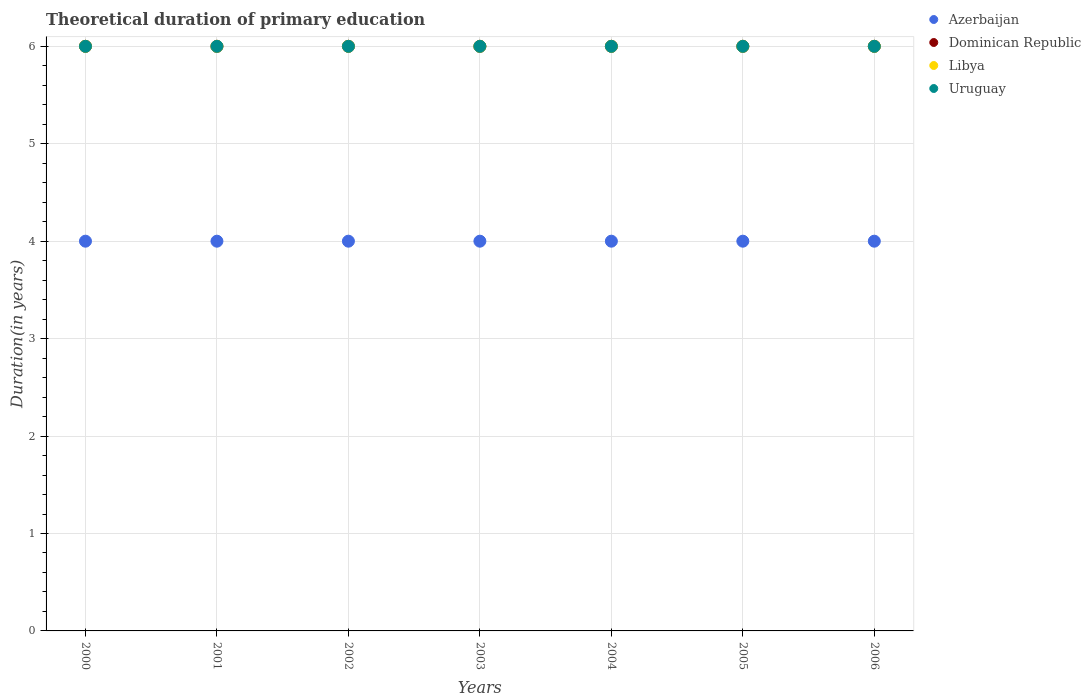Is the number of dotlines equal to the number of legend labels?
Offer a very short reply. Yes. What is the total theoretical duration of primary education in Azerbaijan in 2005?
Make the answer very short. 4. Across all years, what is the minimum total theoretical duration of primary education in Azerbaijan?
Your answer should be compact. 4. In which year was the total theoretical duration of primary education in Azerbaijan maximum?
Your answer should be compact. 2000. In which year was the total theoretical duration of primary education in Azerbaijan minimum?
Offer a very short reply. 2000. What is the total total theoretical duration of primary education in Uruguay in the graph?
Your answer should be compact. 42. What is the average total theoretical duration of primary education in Libya per year?
Make the answer very short. 6. In the year 2005, what is the difference between the total theoretical duration of primary education in Azerbaijan and total theoretical duration of primary education in Libya?
Offer a terse response. -2. In how many years, is the total theoretical duration of primary education in Dominican Republic greater than 2.2 years?
Keep it short and to the point. 7. What is the ratio of the total theoretical duration of primary education in Azerbaijan in 2002 to that in 2004?
Offer a very short reply. 1. Is the total theoretical duration of primary education in Dominican Republic in 2000 less than that in 2006?
Make the answer very short. No. Is the difference between the total theoretical duration of primary education in Azerbaijan in 2001 and 2003 greater than the difference between the total theoretical duration of primary education in Libya in 2001 and 2003?
Provide a succinct answer. No. What is the difference between the highest and the lowest total theoretical duration of primary education in Azerbaijan?
Offer a terse response. 0. Is the total theoretical duration of primary education in Dominican Republic strictly greater than the total theoretical duration of primary education in Uruguay over the years?
Your answer should be compact. No. Is the total theoretical duration of primary education in Azerbaijan strictly less than the total theoretical duration of primary education in Dominican Republic over the years?
Keep it short and to the point. Yes. How many years are there in the graph?
Your answer should be very brief. 7. Are the values on the major ticks of Y-axis written in scientific E-notation?
Keep it short and to the point. No. Does the graph contain grids?
Offer a terse response. Yes. Where does the legend appear in the graph?
Your answer should be compact. Top right. How are the legend labels stacked?
Give a very brief answer. Vertical. What is the title of the graph?
Make the answer very short. Theoretical duration of primary education. Does "United States" appear as one of the legend labels in the graph?
Ensure brevity in your answer.  No. What is the label or title of the Y-axis?
Make the answer very short. Duration(in years). What is the Duration(in years) in Dominican Republic in 2000?
Give a very brief answer. 6. What is the Duration(in years) of Uruguay in 2000?
Keep it short and to the point. 6. What is the Duration(in years) of Azerbaijan in 2001?
Provide a short and direct response. 4. What is the Duration(in years) in Dominican Republic in 2001?
Offer a terse response. 6. What is the Duration(in years) in Libya in 2001?
Your answer should be very brief. 6. What is the Duration(in years) in Uruguay in 2001?
Provide a short and direct response. 6. What is the Duration(in years) in Dominican Republic in 2002?
Make the answer very short. 6. What is the Duration(in years) in Uruguay in 2002?
Ensure brevity in your answer.  6. What is the Duration(in years) in Libya in 2003?
Offer a very short reply. 6. What is the Duration(in years) in Uruguay in 2003?
Your response must be concise. 6. What is the Duration(in years) in Dominican Republic in 2004?
Provide a short and direct response. 6. What is the Duration(in years) in Libya in 2005?
Provide a succinct answer. 6. What is the Duration(in years) in Uruguay in 2005?
Keep it short and to the point. 6. What is the Duration(in years) of Azerbaijan in 2006?
Give a very brief answer. 4. What is the Duration(in years) in Libya in 2006?
Keep it short and to the point. 6. What is the Duration(in years) in Uruguay in 2006?
Offer a terse response. 6. Across all years, what is the maximum Duration(in years) of Azerbaijan?
Offer a terse response. 4. Across all years, what is the maximum Duration(in years) in Libya?
Your answer should be compact. 6. Across all years, what is the maximum Duration(in years) in Uruguay?
Give a very brief answer. 6. Across all years, what is the minimum Duration(in years) in Azerbaijan?
Ensure brevity in your answer.  4. Across all years, what is the minimum Duration(in years) in Libya?
Give a very brief answer. 6. What is the total Duration(in years) of Azerbaijan in the graph?
Your response must be concise. 28. What is the total Duration(in years) of Dominican Republic in the graph?
Ensure brevity in your answer.  42. What is the total Duration(in years) in Libya in the graph?
Provide a succinct answer. 42. What is the difference between the Duration(in years) in Dominican Republic in 2000 and that in 2001?
Keep it short and to the point. 0. What is the difference between the Duration(in years) in Libya in 2000 and that in 2001?
Provide a succinct answer. 0. What is the difference between the Duration(in years) in Azerbaijan in 2000 and that in 2002?
Provide a succinct answer. 0. What is the difference between the Duration(in years) of Uruguay in 2000 and that in 2002?
Your answer should be compact. 0. What is the difference between the Duration(in years) in Uruguay in 2000 and that in 2003?
Make the answer very short. 0. What is the difference between the Duration(in years) in Azerbaijan in 2000 and that in 2004?
Ensure brevity in your answer.  0. What is the difference between the Duration(in years) in Dominican Republic in 2000 and that in 2004?
Provide a succinct answer. 0. What is the difference between the Duration(in years) in Libya in 2000 and that in 2005?
Your answer should be compact. 0. What is the difference between the Duration(in years) in Dominican Republic in 2000 and that in 2006?
Your answer should be compact. 0. What is the difference between the Duration(in years) of Libya in 2000 and that in 2006?
Keep it short and to the point. 0. What is the difference between the Duration(in years) in Uruguay in 2000 and that in 2006?
Your answer should be very brief. 0. What is the difference between the Duration(in years) in Dominican Republic in 2001 and that in 2003?
Give a very brief answer. 0. What is the difference between the Duration(in years) of Libya in 2001 and that in 2003?
Give a very brief answer. 0. What is the difference between the Duration(in years) in Uruguay in 2001 and that in 2004?
Offer a very short reply. 0. What is the difference between the Duration(in years) of Azerbaijan in 2001 and that in 2005?
Offer a terse response. 0. What is the difference between the Duration(in years) in Libya in 2001 and that in 2005?
Provide a short and direct response. 0. What is the difference between the Duration(in years) in Azerbaijan in 2001 and that in 2006?
Provide a succinct answer. 0. What is the difference between the Duration(in years) in Libya in 2001 and that in 2006?
Give a very brief answer. 0. What is the difference between the Duration(in years) in Uruguay in 2001 and that in 2006?
Your answer should be compact. 0. What is the difference between the Duration(in years) of Azerbaijan in 2002 and that in 2003?
Make the answer very short. 0. What is the difference between the Duration(in years) in Libya in 2002 and that in 2003?
Your response must be concise. 0. What is the difference between the Duration(in years) of Azerbaijan in 2002 and that in 2004?
Provide a short and direct response. 0. What is the difference between the Duration(in years) in Dominican Republic in 2002 and that in 2004?
Give a very brief answer. 0. What is the difference between the Duration(in years) in Azerbaijan in 2002 and that in 2005?
Your response must be concise. 0. What is the difference between the Duration(in years) of Dominican Republic in 2002 and that in 2005?
Your answer should be very brief. 0. What is the difference between the Duration(in years) of Azerbaijan in 2002 and that in 2006?
Ensure brevity in your answer.  0. What is the difference between the Duration(in years) in Dominican Republic in 2002 and that in 2006?
Offer a very short reply. 0. What is the difference between the Duration(in years) of Azerbaijan in 2003 and that in 2004?
Offer a very short reply. 0. What is the difference between the Duration(in years) of Dominican Republic in 2003 and that in 2004?
Make the answer very short. 0. What is the difference between the Duration(in years) of Uruguay in 2003 and that in 2004?
Provide a succinct answer. 0. What is the difference between the Duration(in years) in Dominican Republic in 2003 and that in 2005?
Provide a succinct answer. 0. What is the difference between the Duration(in years) of Uruguay in 2003 and that in 2005?
Your response must be concise. 0. What is the difference between the Duration(in years) of Azerbaijan in 2003 and that in 2006?
Offer a terse response. 0. What is the difference between the Duration(in years) of Uruguay in 2003 and that in 2006?
Your answer should be very brief. 0. What is the difference between the Duration(in years) in Azerbaijan in 2004 and that in 2005?
Provide a succinct answer. 0. What is the difference between the Duration(in years) in Dominican Republic in 2004 and that in 2005?
Give a very brief answer. 0. What is the difference between the Duration(in years) of Libya in 2004 and that in 2005?
Provide a short and direct response. 0. What is the difference between the Duration(in years) in Uruguay in 2004 and that in 2005?
Ensure brevity in your answer.  0. What is the difference between the Duration(in years) of Azerbaijan in 2004 and that in 2006?
Your answer should be very brief. 0. What is the difference between the Duration(in years) of Dominican Republic in 2004 and that in 2006?
Your answer should be compact. 0. What is the difference between the Duration(in years) in Azerbaijan in 2000 and the Duration(in years) in Libya in 2001?
Provide a short and direct response. -2. What is the difference between the Duration(in years) of Dominican Republic in 2000 and the Duration(in years) of Libya in 2001?
Make the answer very short. 0. What is the difference between the Duration(in years) in Libya in 2000 and the Duration(in years) in Uruguay in 2001?
Offer a very short reply. 0. What is the difference between the Duration(in years) in Azerbaijan in 2000 and the Duration(in years) in Uruguay in 2002?
Offer a very short reply. -2. What is the difference between the Duration(in years) of Dominican Republic in 2000 and the Duration(in years) of Libya in 2002?
Make the answer very short. 0. What is the difference between the Duration(in years) of Libya in 2000 and the Duration(in years) of Uruguay in 2002?
Your answer should be compact. 0. What is the difference between the Duration(in years) in Azerbaijan in 2000 and the Duration(in years) in Dominican Republic in 2003?
Give a very brief answer. -2. What is the difference between the Duration(in years) in Dominican Republic in 2000 and the Duration(in years) in Uruguay in 2003?
Offer a very short reply. 0. What is the difference between the Duration(in years) in Azerbaijan in 2000 and the Duration(in years) in Libya in 2004?
Ensure brevity in your answer.  -2. What is the difference between the Duration(in years) of Dominican Republic in 2000 and the Duration(in years) of Libya in 2004?
Ensure brevity in your answer.  0. What is the difference between the Duration(in years) of Libya in 2000 and the Duration(in years) of Uruguay in 2004?
Offer a very short reply. 0. What is the difference between the Duration(in years) of Azerbaijan in 2000 and the Duration(in years) of Dominican Republic in 2005?
Keep it short and to the point. -2. What is the difference between the Duration(in years) in Dominican Republic in 2000 and the Duration(in years) in Libya in 2005?
Ensure brevity in your answer.  0. What is the difference between the Duration(in years) in Dominican Republic in 2000 and the Duration(in years) in Uruguay in 2005?
Offer a terse response. 0. What is the difference between the Duration(in years) in Libya in 2000 and the Duration(in years) in Uruguay in 2005?
Keep it short and to the point. 0. What is the difference between the Duration(in years) of Dominican Republic in 2000 and the Duration(in years) of Uruguay in 2006?
Your answer should be compact. 0. What is the difference between the Duration(in years) in Libya in 2000 and the Duration(in years) in Uruguay in 2006?
Your answer should be very brief. 0. What is the difference between the Duration(in years) of Dominican Republic in 2001 and the Duration(in years) of Libya in 2002?
Offer a terse response. 0. What is the difference between the Duration(in years) of Dominican Republic in 2001 and the Duration(in years) of Uruguay in 2002?
Your response must be concise. 0. What is the difference between the Duration(in years) in Libya in 2001 and the Duration(in years) in Uruguay in 2002?
Provide a short and direct response. 0. What is the difference between the Duration(in years) in Azerbaijan in 2001 and the Duration(in years) in Dominican Republic in 2003?
Offer a very short reply. -2. What is the difference between the Duration(in years) in Azerbaijan in 2001 and the Duration(in years) in Uruguay in 2003?
Ensure brevity in your answer.  -2. What is the difference between the Duration(in years) in Dominican Republic in 2001 and the Duration(in years) in Uruguay in 2003?
Your answer should be very brief. 0. What is the difference between the Duration(in years) of Azerbaijan in 2001 and the Duration(in years) of Dominican Republic in 2004?
Offer a very short reply. -2. What is the difference between the Duration(in years) in Azerbaijan in 2001 and the Duration(in years) in Libya in 2005?
Ensure brevity in your answer.  -2. What is the difference between the Duration(in years) in Dominican Republic in 2001 and the Duration(in years) in Libya in 2005?
Give a very brief answer. 0. What is the difference between the Duration(in years) in Dominican Republic in 2001 and the Duration(in years) in Uruguay in 2005?
Your answer should be compact. 0. What is the difference between the Duration(in years) of Dominican Republic in 2001 and the Duration(in years) of Uruguay in 2006?
Ensure brevity in your answer.  0. What is the difference between the Duration(in years) in Azerbaijan in 2002 and the Duration(in years) in Libya in 2003?
Ensure brevity in your answer.  -2. What is the difference between the Duration(in years) in Azerbaijan in 2002 and the Duration(in years) in Uruguay in 2003?
Provide a short and direct response. -2. What is the difference between the Duration(in years) in Dominican Republic in 2002 and the Duration(in years) in Libya in 2003?
Your answer should be very brief. 0. What is the difference between the Duration(in years) of Dominican Republic in 2002 and the Duration(in years) of Uruguay in 2003?
Your answer should be very brief. 0. What is the difference between the Duration(in years) of Azerbaijan in 2002 and the Duration(in years) of Uruguay in 2004?
Provide a short and direct response. -2. What is the difference between the Duration(in years) of Dominican Republic in 2002 and the Duration(in years) of Libya in 2004?
Your answer should be compact. 0. What is the difference between the Duration(in years) of Azerbaijan in 2002 and the Duration(in years) of Uruguay in 2005?
Keep it short and to the point. -2. What is the difference between the Duration(in years) of Dominican Republic in 2002 and the Duration(in years) of Libya in 2005?
Keep it short and to the point. 0. What is the difference between the Duration(in years) in Dominican Republic in 2002 and the Duration(in years) in Uruguay in 2005?
Make the answer very short. 0. What is the difference between the Duration(in years) in Libya in 2002 and the Duration(in years) in Uruguay in 2005?
Give a very brief answer. 0. What is the difference between the Duration(in years) in Dominican Republic in 2002 and the Duration(in years) in Uruguay in 2006?
Your response must be concise. 0. What is the difference between the Duration(in years) in Libya in 2002 and the Duration(in years) in Uruguay in 2006?
Your response must be concise. 0. What is the difference between the Duration(in years) of Azerbaijan in 2003 and the Duration(in years) of Libya in 2004?
Offer a terse response. -2. What is the difference between the Duration(in years) in Azerbaijan in 2003 and the Duration(in years) in Uruguay in 2004?
Keep it short and to the point. -2. What is the difference between the Duration(in years) in Dominican Republic in 2003 and the Duration(in years) in Libya in 2004?
Ensure brevity in your answer.  0. What is the difference between the Duration(in years) in Dominican Republic in 2003 and the Duration(in years) in Uruguay in 2004?
Provide a succinct answer. 0. What is the difference between the Duration(in years) of Libya in 2003 and the Duration(in years) of Uruguay in 2004?
Make the answer very short. 0. What is the difference between the Duration(in years) of Azerbaijan in 2003 and the Duration(in years) of Dominican Republic in 2005?
Your answer should be compact. -2. What is the difference between the Duration(in years) of Azerbaijan in 2003 and the Duration(in years) of Libya in 2005?
Ensure brevity in your answer.  -2. What is the difference between the Duration(in years) of Azerbaijan in 2003 and the Duration(in years) of Uruguay in 2005?
Ensure brevity in your answer.  -2. What is the difference between the Duration(in years) of Dominican Republic in 2003 and the Duration(in years) of Libya in 2005?
Offer a terse response. 0. What is the difference between the Duration(in years) in Azerbaijan in 2003 and the Duration(in years) in Libya in 2006?
Your answer should be very brief. -2. What is the difference between the Duration(in years) in Dominican Republic in 2003 and the Duration(in years) in Uruguay in 2006?
Provide a succinct answer. 0. What is the difference between the Duration(in years) in Libya in 2003 and the Duration(in years) in Uruguay in 2006?
Ensure brevity in your answer.  0. What is the difference between the Duration(in years) in Azerbaijan in 2004 and the Duration(in years) in Dominican Republic in 2005?
Offer a very short reply. -2. What is the difference between the Duration(in years) in Azerbaijan in 2004 and the Duration(in years) in Uruguay in 2005?
Your answer should be very brief. -2. What is the difference between the Duration(in years) in Dominican Republic in 2004 and the Duration(in years) in Libya in 2005?
Give a very brief answer. 0. What is the difference between the Duration(in years) in Dominican Republic in 2004 and the Duration(in years) in Uruguay in 2005?
Offer a very short reply. 0. What is the difference between the Duration(in years) of Libya in 2004 and the Duration(in years) of Uruguay in 2005?
Your answer should be compact. 0. What is the difference between the Duration(in years) in Azerbaijan in 2004 and the Duration(in years) in Dominican Republic in 2006?
Offer a very short reply. -2. What is the difference between the Duration(in years) of Azerbaijan in 2004 and the Duration(in years) of Uruguay in 2006?
Provide a succinct answer. -2. What is the difference between the Duration(in years) in Dominican Republic in 2004 and the Duration(in years) in Uruguay in 2006?
Keep it short and to the point. 0. What is the difference between the Duration(in years) in Azerbaijan in 2005 and the Duration(in years) in Libya in 2006?
Ensure brevity in your answer.  -2. What is the average Duration(in years) of Azerbaijan per year?
Provide a succinct answer. 4. What is the average Duration(in years) of Dominican Republic per year?
Offer a terse response. 6. In the year 2000, what is the difference between the Duration(in years) of Dominican Republic and Duration(in years) of Libya?
Your answer should be compact. 0. In the year 2000, what is the difference between the Duration(in years) in Libya and Duration(in years) in Uruguay?
Provide a succinct answer. 0. In the year 2001, what is the difference between the Duration(in years) of Azerbaijan and Duration(in years) of Dominican Republic?
Your answer should be very brief. -2. In the year 2001, what is the difference between the Duration(in years) of Azerbaijan and Duration(in years) of Uruguay?
Provide a short and direct response. -2. In the year 2001, what is the difference between the Duration(in years) in Dominican Republic and Duration(in years) in Libya?
Your answer should be very brief. 0. In the year 2002, what is the difference between the Duration(in years) of Azerbaijan and Duration(in years) of Dominican Republic?
Your answer should be very brief. -2. In the year 2002, what is the difference between the Duration(in years) in Azerbaijan and Duration(in years) in Libya?
Offer a very short reply. -2. In the year 2002, what is the difference between the Duration(in years) in Dominican Republic and Duration(in years) in Libya?
Keep it short and to the point. 0. In the year 2002, what is the difference between the Duration(in years) in Dominican Republic and Duration(in years) in Uruguay?
Make the answer very short. 0. In the year 2002, what is the difference between the Duration(in years) of Libya and Duration(in years) of Uruguay?
Your answer should be compact. 0. In the year 2003, what is the difference between the Duration(in years) of Azerbaijan and Duration(in years) of Dominican Republic?
Give a very brief answer. -2. In the year 2003, what is the difference between the Duration(in years) of Azerbaijan and Duration(in years) of Uruguay?
Keep it short and to the point. -2. In the year 2003, what is the difference between the Duration(in years) of Libya and Duration(in years) of Uruguay?
Your answer should be very brief. 0. In the year 2004, what is the difference between the Duration(in years) in Azerbaijan and Duration(in years) in Libya?
Ensure brevity in your answer.  -2. In the year 2004, what is the difference between the Duration(in years) of Azerbaijan and Duration(in years) of Uruguay?
Keep it short and to the point. -2. In the year 2004, what is the difference between the Duration(in years) in Dominican Republic and Duration(in years) in Libya?
Provide a short and direct response. 0. In the year 2004, what is the difference between the Duration(in years) in Dominican Republic and Duration(in years) in Uruguay?
Ensure brevity in your answer.  0. In the year 2005, what is the difference between the Duration(in years) of Azerbaijan and Duration(in years) of Dominican Republic?
Your response must be concise. -2. In the year 2005, what is the difference between the Duration(in years) in Azerbaijan and Duration(in years) in Uruguay?
Make the answer very short. -2. In the year 2005, what is the difference between the Duration(in years) of Dominican Republic and Duration(in years) of Libya?
Your answer should be compact. 0. In the year 2005, what is the difference between the Duration(in years) in Dominican Republic and Duration(in years) in Uruguay?
Your answer should be very brief. 0. In the year 2005, what is the difference between the Duration(in years) in Libya and Duration(in years) in Uruguay?
Your answer should be compact. 0. In the year 2006, what is the difference between the Duration(in years) in Azerbaijan and Duration(in years) in Dominican Republic?
Your answer should be very brief. -2. In the year 2006, what is the difference between the Duration(in years) in Dominican Republic and Duration(in years) in Libya?
Offer a terse response. 0. What is the ratio of the Duration(in years) in Dominican Republic in 2000 to that in 2001?
Your answer should be very brief. 1. What is the ratio of the Duration(in years) of Libya in 2000 to that in 2001?
Offer a very short reply. 1. What is the ratio of the Duration(in years) in Azerbaijan in 2000 to that in 2002?
Offer a terse response. 1. What is the ratio of the Duration(in years) of Libya in 2000 to that in 2002?
Give a very brief answer. 1. What is the ratio of the Duration(in years) of Uruguay in 2000 to that in 2003?
Your answer should be compact. 1. What is the ratio of the Duration(in years) in Azerbaijan in 2000 to that in 2004?
Offer a terse response. 1. What is the ratio of the Duration(in years) in Libya in 2000 to that in 2004?
Make the answer very short. 1. What is the ratio of the Duration(in years) in Dominican Republic in 2000 to that in 2005?
Provide a short and direct response. 1. What is the ratio of the Duration(in years) in Libya in 2000 to that in 2005?
Provide a succinct answer. 1. What is the ratio of the Duration(in years) in Azerbaijan in 2000 to that in 2006?
Ensure brevity in your answer.  1. What is the ratio of the Duration(in years) in Uruguay in 2000 to that in 2006?
Ensure brevity in your answer.  1. What is the ratio of the Duration(in years) of Azerbaijan in 2001 to that in 2002?
Provide a short and direct response. 1. What is the ratio of the Duration(in years) in Libya in 2001 to that in 2002?
Provide a short and direct response. 1. What is the ratio of the Duration(in years) of Uruguay in 2001 to that in 2002?
Offer a terse response. 1. What is the ratio of the Duration(in years) of Azerbaijan in 2001 to that in 2003?
Your response must be concise. 1. What is the ratio of the Duration(in years) of Uruguay in 2001 to that in 2003?
Your answer should be compact. 1. What is the ratio of the Duration(in years) of Dominican Republic in 2001 to that in 2004?
Your response must be concise. 1. What is the ratio of the Duration(in years) in Libya in 2001 to that in 2004?
Provide a succinct answer. 1. What is the ratio of the Duration(in years) in Uruguay in 2001 to that in 2004?
Give a very brief answer. 1. What is the ratio of the Duration(in years) in Dominican Republic in 2001 to that in 2005?
Offer a terse response. 1. What is the ratio of the Duration(in years) of Uruguay in 2001 to that in 2005?
Your response must be concise. 1. What is the ratio of the Duration(in years) of Dominican Republic in 2001 to that in 2006?
Offer a very short reply. 1. What is the ratio of the Duration(in years) in Dominican Republic in 2002 to that in 2003?
Make the answer very short. 1. What is the ratio of the Duration(in years) of Uruguay in 2002 to that in 2003?
Your answer should be very brief. 1. What is the ratio of the Duration(in years) of Dominican Republic in 2002 to that in 2004?
Make the answer very short. 1. What is the ratio of the Duration(in years) in Libya in 2002 to that in 2004?
Offer a terse response. 1. What is the ratio of the Duration(in years) in Azerbaijan in 2002 to that in 2005?
Provide a short and direct response. 1. What is the ratio of the Duration(in years) of Dominican Republic in 2002 to that in 2005?
Ensure brevity in your answer.  1. What is the ratio of the Duration(in years) in Libya in 2002 to that in 2005?
Ensure brevity in your answer.  1. What is the ratio of the Duration(in years) in Libya in 2002 to that in 2006?
Give a very brief answer. 1. What is the ratio of the Duration(in years) of Uruguay in 2002 to that in 2006?
Offer a very short reply. 1. What is the ratio of the Duration(in years) in Azerbaijan in 2003 to that in 2004?
Give a very brief answer. 1. What is the ratio of the Duration(in years) of Dominican Republic in 2003 to that in 2004?
Ensure brevity in your answer.  1. What is the ratio of the Duration(in years) in Dominican Republic in 2003 to that in 2005?
Provide a succinct answer. 1. What is the ratio of the Duration(in years) of Libya in 2003 to that in 2005?
Ensure brevity in your answer.  1. What is the ratio of the Duration(in years) in Dominican Republic in 2003 to that in 2006?
Your answer should be compact. 1. What is the ratio of the Duration(in years) of Libya in 2003 to that in 2006?
Make the answer very short. 1. What is the ratio of the Duration(in years) in Uruguay in 2003 to that in 2006?
Provide a short and direct response. 1. What is the ratio of the Duration(in years) in Azerbaijan in 2004 to that in 2005?
Offer a terse response. 1. What is the ratio of the Duration(in years) of Uruguay in 2004 to that in 2006?
Offer a very short reply. 1. What is the ratio of the Duration(in years) of Dominican Republic in 2005 to that in 2006?
Give a very brief answer. 1. What is the ratio of the Duration(in years) of Libya in 2005 to that in 2006?
Make the answer very short. 1. What is the ratio of the Duration(in years) in Uruguay in 2005 to that in 2006?
Give a very brief answer. 1. What is the difference between the highest and the second highest Duration(in years) of Azerbaijan?
Keep it short and to the point. 0. What is the difference between the highest and the second highest Duration(in years) in Uruguay?
Offer a very short reply. 0. What is the difference between the highest and the lowest Duration(in years) in Azerbaijan?
Your answer should be compact. 0. What is the difference between the highest and the lowest Duration(in years) in Uruguay?
Offer a terse response. 0. 